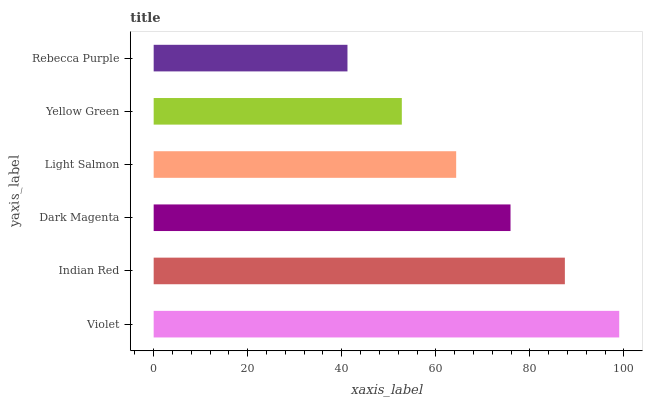Is Rebecca Purple the minimum?
Answer yes or no. Yes. Is Violet the maximum?
Answer yes or no. Yes. Is Indian Red the minimum?
Answer yes or no. No. Is Indian Red the maximum?
Answer yes or no. No. Is Violet greater than Indian Red?
Answer yes or no. Yes. Is Indian Red less than Violet?
Answer yes or no. Yes. Is Indian Red greater than Violet?
Answer yes or no. No. Is Violet less than Indian Red?
Answer yes or no. No. Is Dark Magenta the high median?
Answer yes or no. Yes. Is Light Salmon the low median?
Answer yes or no. Yes. Is Indian Red the high median?
Answer yes or no. No. Is Indian Red the low median?
Answer yes or no. No. 